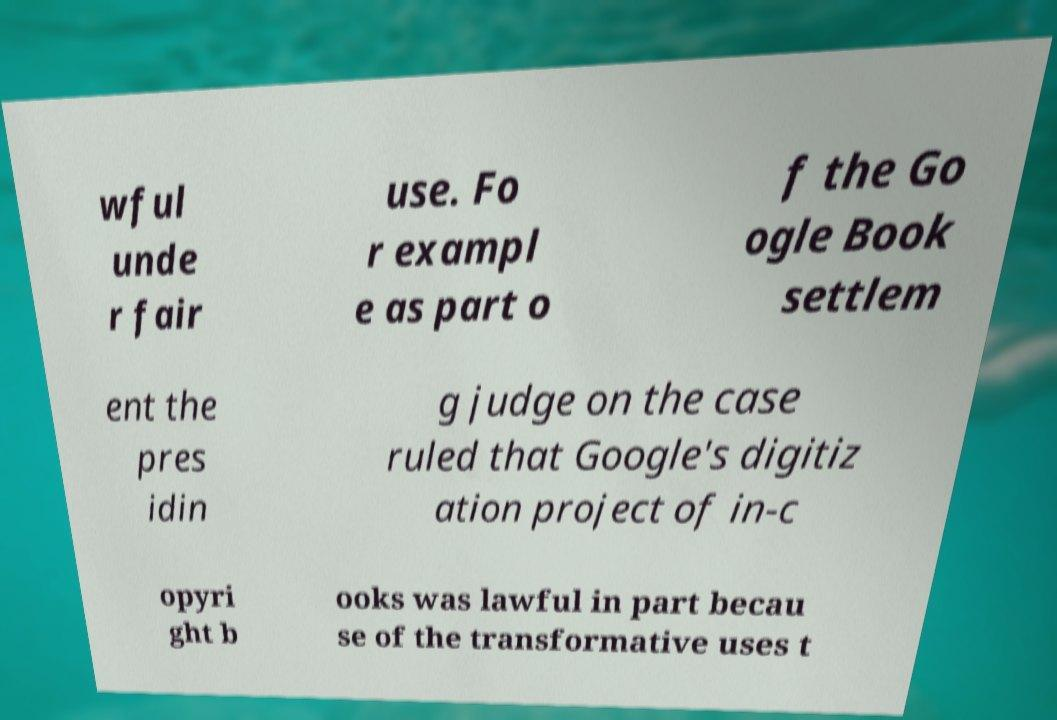There's text embedded in this image that I need extracted. Can you transcribe it verbatim? wful unde r fair use. Fo r exampl e as part o f the Go ogle Book settlem ent the pres idin g judge on the case ruled that Google's digitiz ation project of in-c opyri ght b ooks was lawful in part becau se of the transformative uses t 